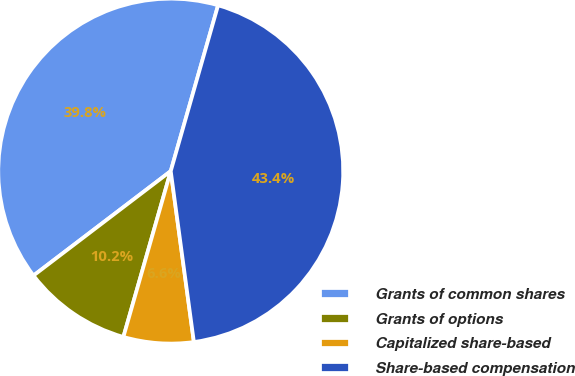<chart> <loc_0><loc_0><loc_500><loc_500><pie_chart><fcel>Grants of common shares<fcel>Grants of options<fcel>Capitalized share-based<fcel>Share-based compensation<nl><fcel>39.78%<fcel>10.22%<fcel>6.57%<fcel>43.43%<nl></chart> 